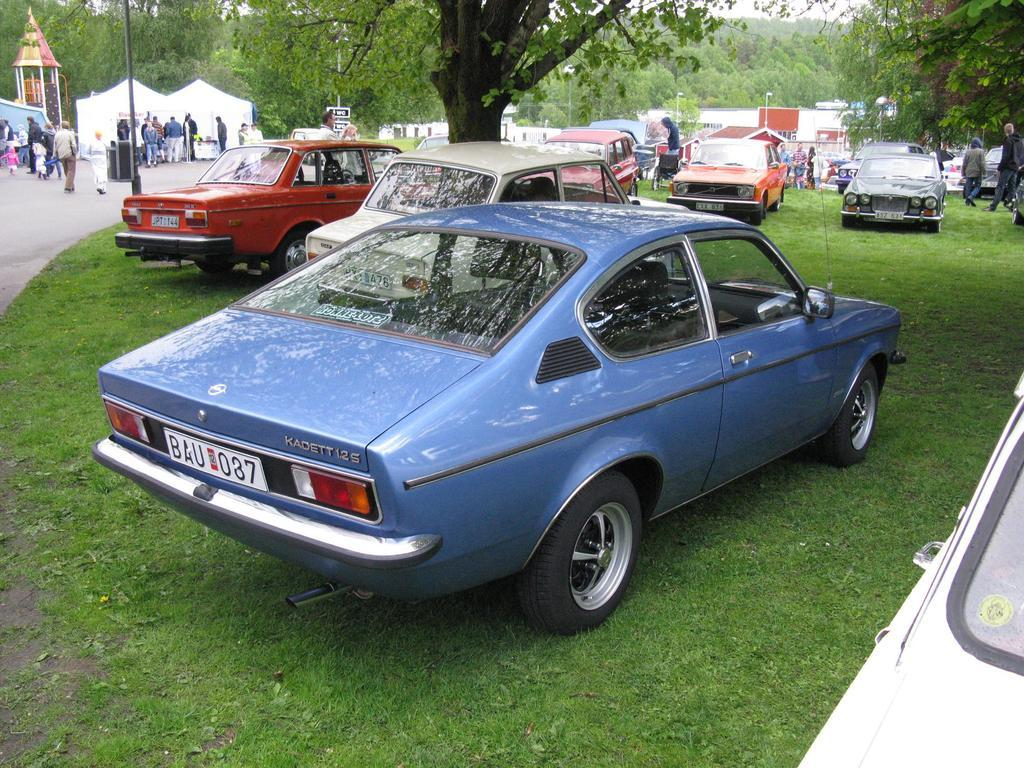What type of vehicles can be seen in the image? There are cars in the image. What type of vegetation is present in the image? There is grass in the image. What structures can be seen in the background of the image? There are tents, houses, and trees in the background of the image. What part of the natural environment is visible in the image? The sky is visible in the background of the image. What type of pest can be seen crawling on the cars in the image? There is no pest visible on the cars in the image. What type of coach is present in the image? There is no coach present in the image. 